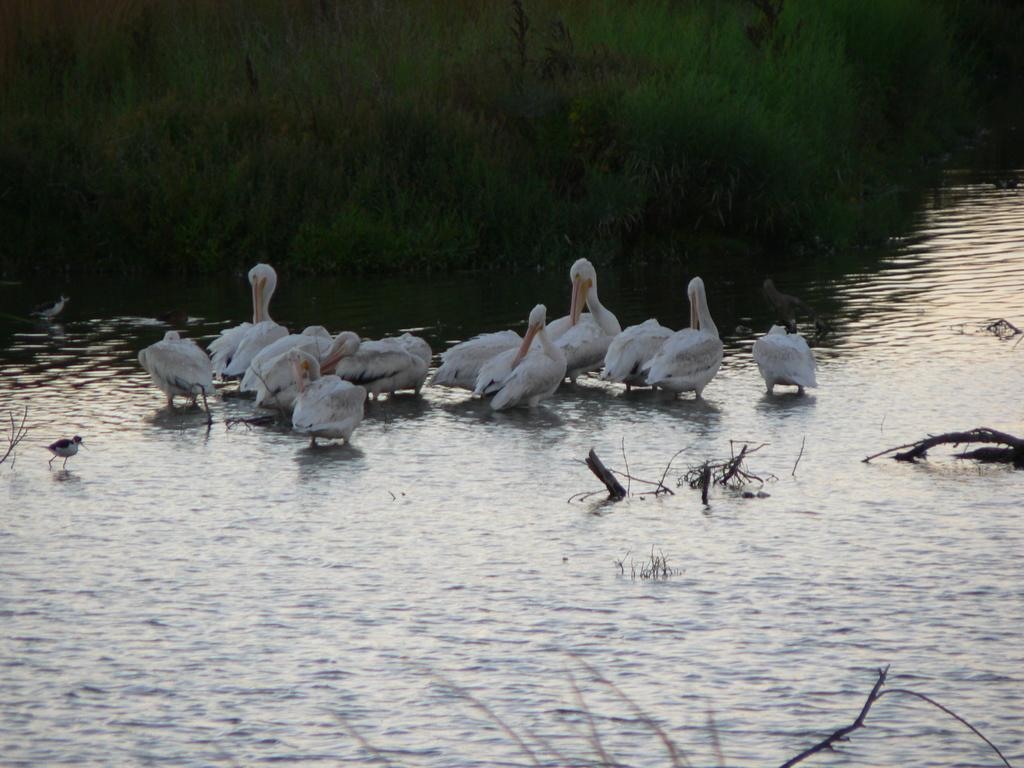What type of animals can be seen in the image? There are white color water birds in the image. Where are the birds located? The birds are on water. Can you hear the birds laughing in the image? There is no sound in the image, so it is not possible to hear the birds laughing. 